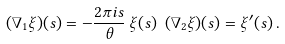<formula> <loc_0><loc_0><loc_500><loc_500>( \nabla _ { 1 } \xi ) ( s ) = - \frac { 2 \pi i s } { \theta } \, \xi ( s ) \ ( \nabla _ { 2 } \xi ) ( s ) = \xi ^ { \prime } ( s ) \, .</formula> 